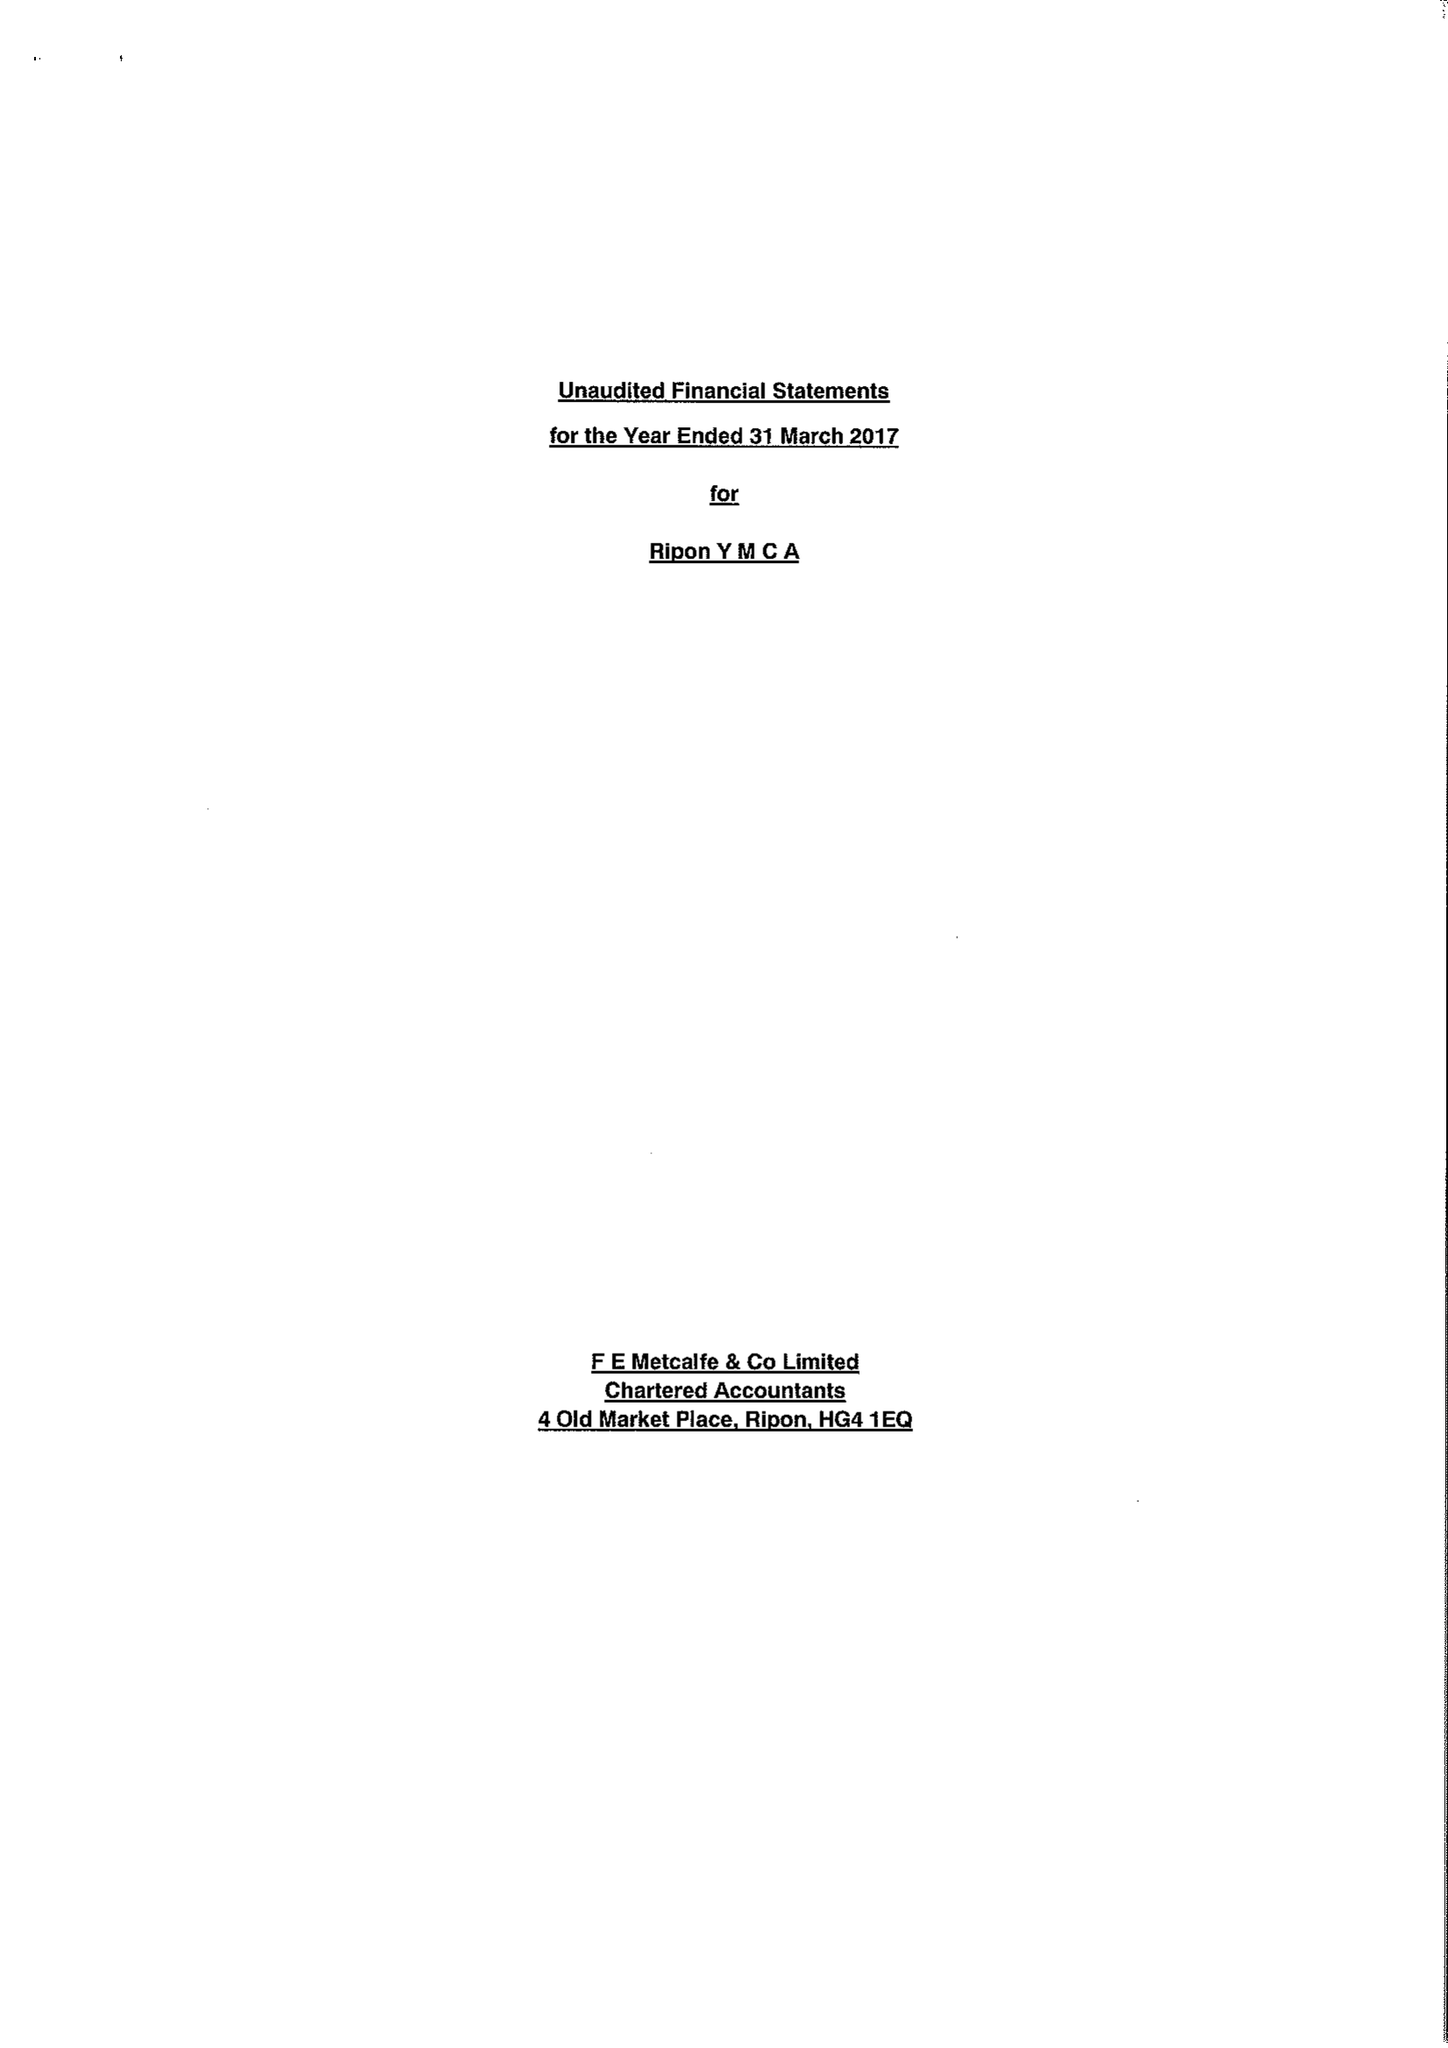What is the value for the charity_name?
Answer the question using a single word or phrase. Ripon Young Men's Christian Association 